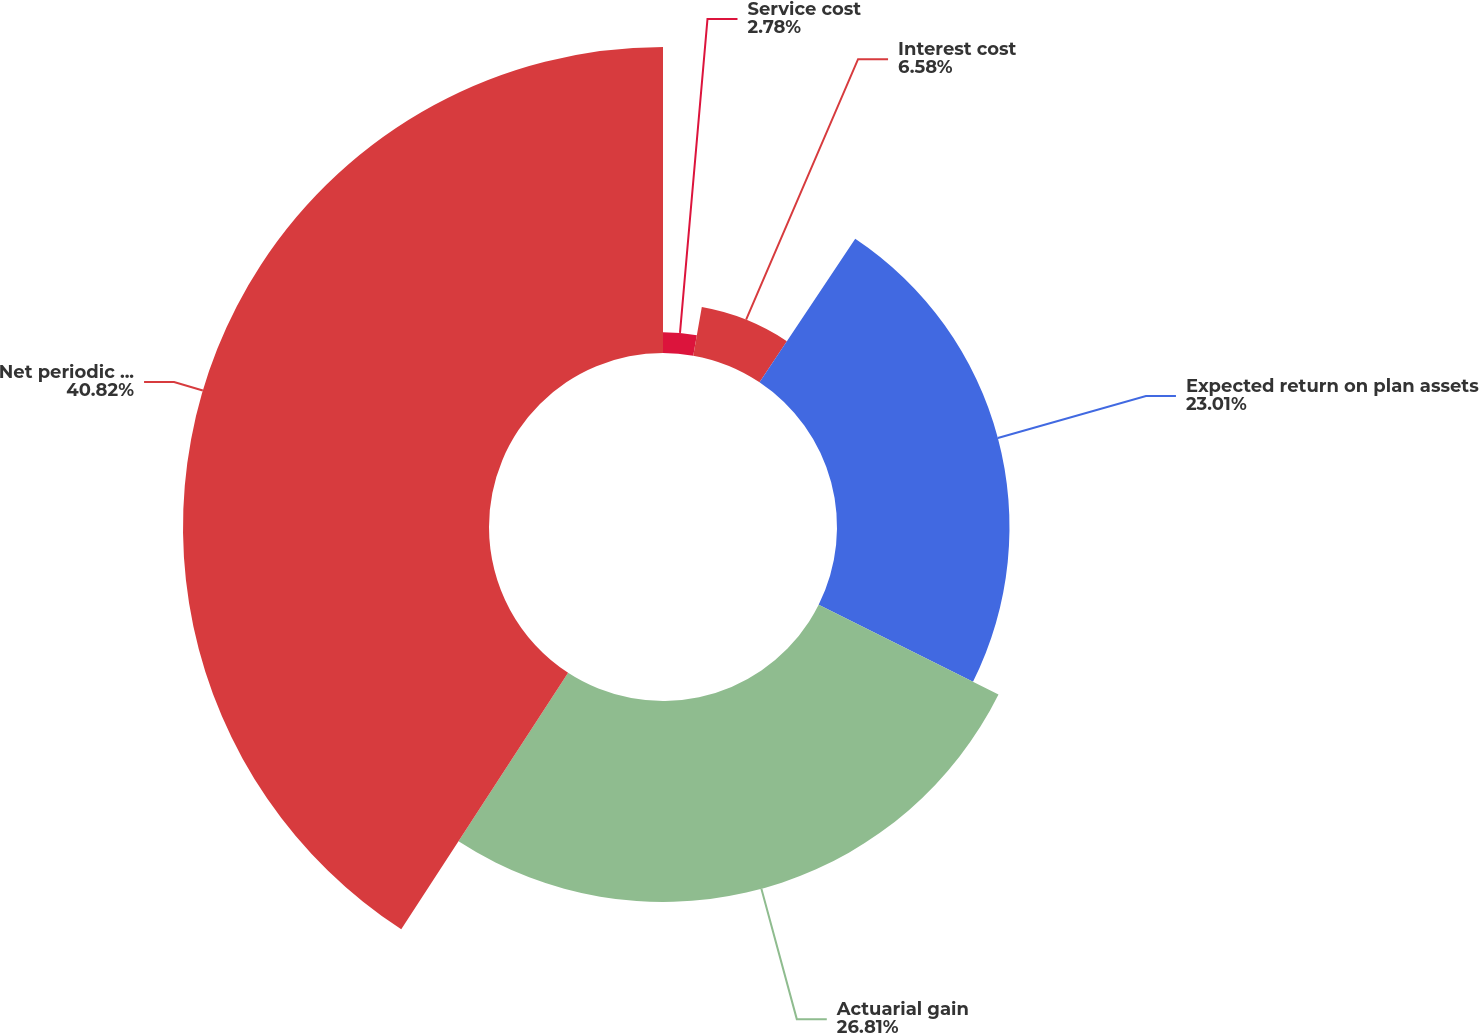Convert chart to OTSL. <chart><loc_0><loc_0><loc_500><loc_500><pie_chart><fcel>Service cost<fcel>Interest cost<fcel>Expected return on plan assets<fcel>Actuarial gain<fcel>Net periodic postretirement<nl><fcel>2.78%<fcel>6.58%<fcel>23.01%<fcel>26.81%<fcel>40.82%<nl></chart> 